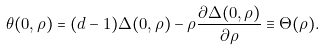Convert formula to latex. <formula><loc_0><loc_0><loc_500><loc_500>\theta ( 0 , \rho ) = ( d - 1 ) \Delta ( 0 , \rho ) - \rho \frac { \partial \Delta ( 0 , \rho ) } { \partial \rho } \equiv \Theta ( \rho ) .</formula> 